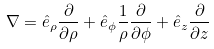<formula> <loc_0><loc_0><loc_500><loc_500>\nabla = \hat { e } _ { \rho } \frac { \partial } { \partial \rho } + \hat { e } _ { \phi } \frac { 1 } { \rho } \frac { \partial } { \partial \phi } + \hat { e } _ { z } \frac { \partial } { \partial z }</formula> 